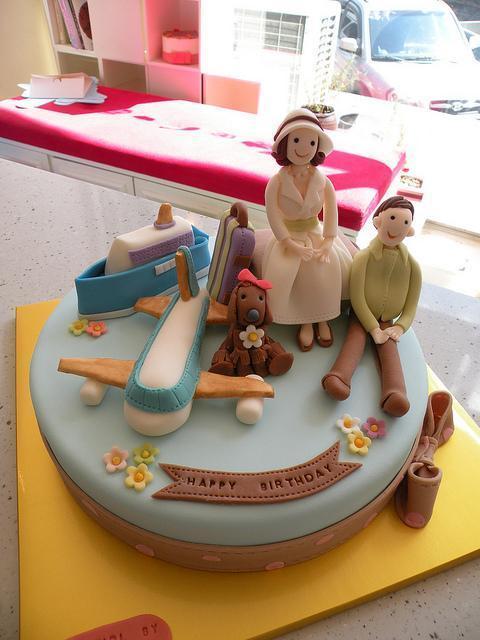Does the caption "The boat is behind the cake." correctly depict the image?
Answer yes or no. No. 